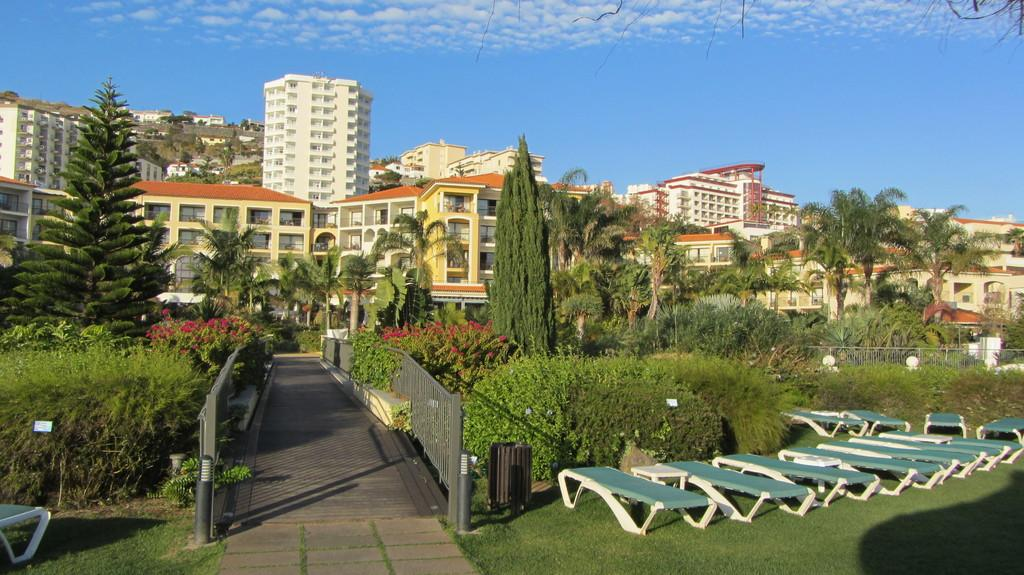What type of ground is visible in the image? The ground in the image is covered with grass. What other types of vegetation can be seen in the image? There are plants and bushes visible in the image. What can be seen in the background of the image? There are trees and buildings in the background of the image. What is visible at the top of the image? The sky is clear and visible at the top of the image. What type of lamp is hanging from the tree in the image? There is no lamp hanging from a tree in the image; it only features grass, plants, bushes, trees, buildings, and a clear sky. What time of day is it in the image? The time of day cannot be determined from the image alone, as there are no specific indicators of time. 